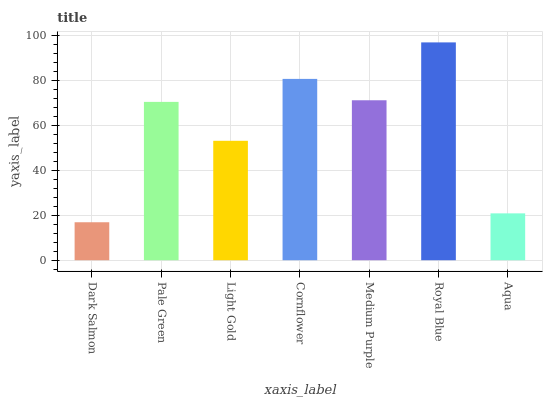Is Dark Salmon the minimum?
Answer yes or no. Yes. Is Royal Blue the maximum?
Answer yes or no. Yes. Is Pale Green the minimum?
Answer yes or no. No. Is Pale Green the maximum?
Answer yes or no. No. Is Pale Green greater than Dark Salmon?
Answer yes or no. Yes. Is Dark Salmon less than Pale Green?
Answer yes or no. Yes. Is Dark Salmon greater than Pale Green?
Answer yes or no. No. Is Pale Green less than Dark Salmon?
Answer yes or no. No. Is Pale Green the high median?
Answer yes or no. Yes. Is Pale Green the low median?
Answer yes or no. Yes. Is Aqua the high median?
Answer yes or no. No. Is Royal Blue the low median?
Answer yes or no. No. 